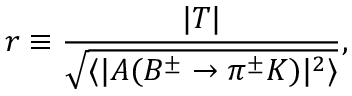<formula> <loc_0><loc_0><loc_500><loc_500>r \equiv \frac { | T | } { \sqrt { \langle | A ( B ^ { \pm } \to \pi ^ { \pm } K ) | ^ { 2 } \rangle } } ,</formula> 